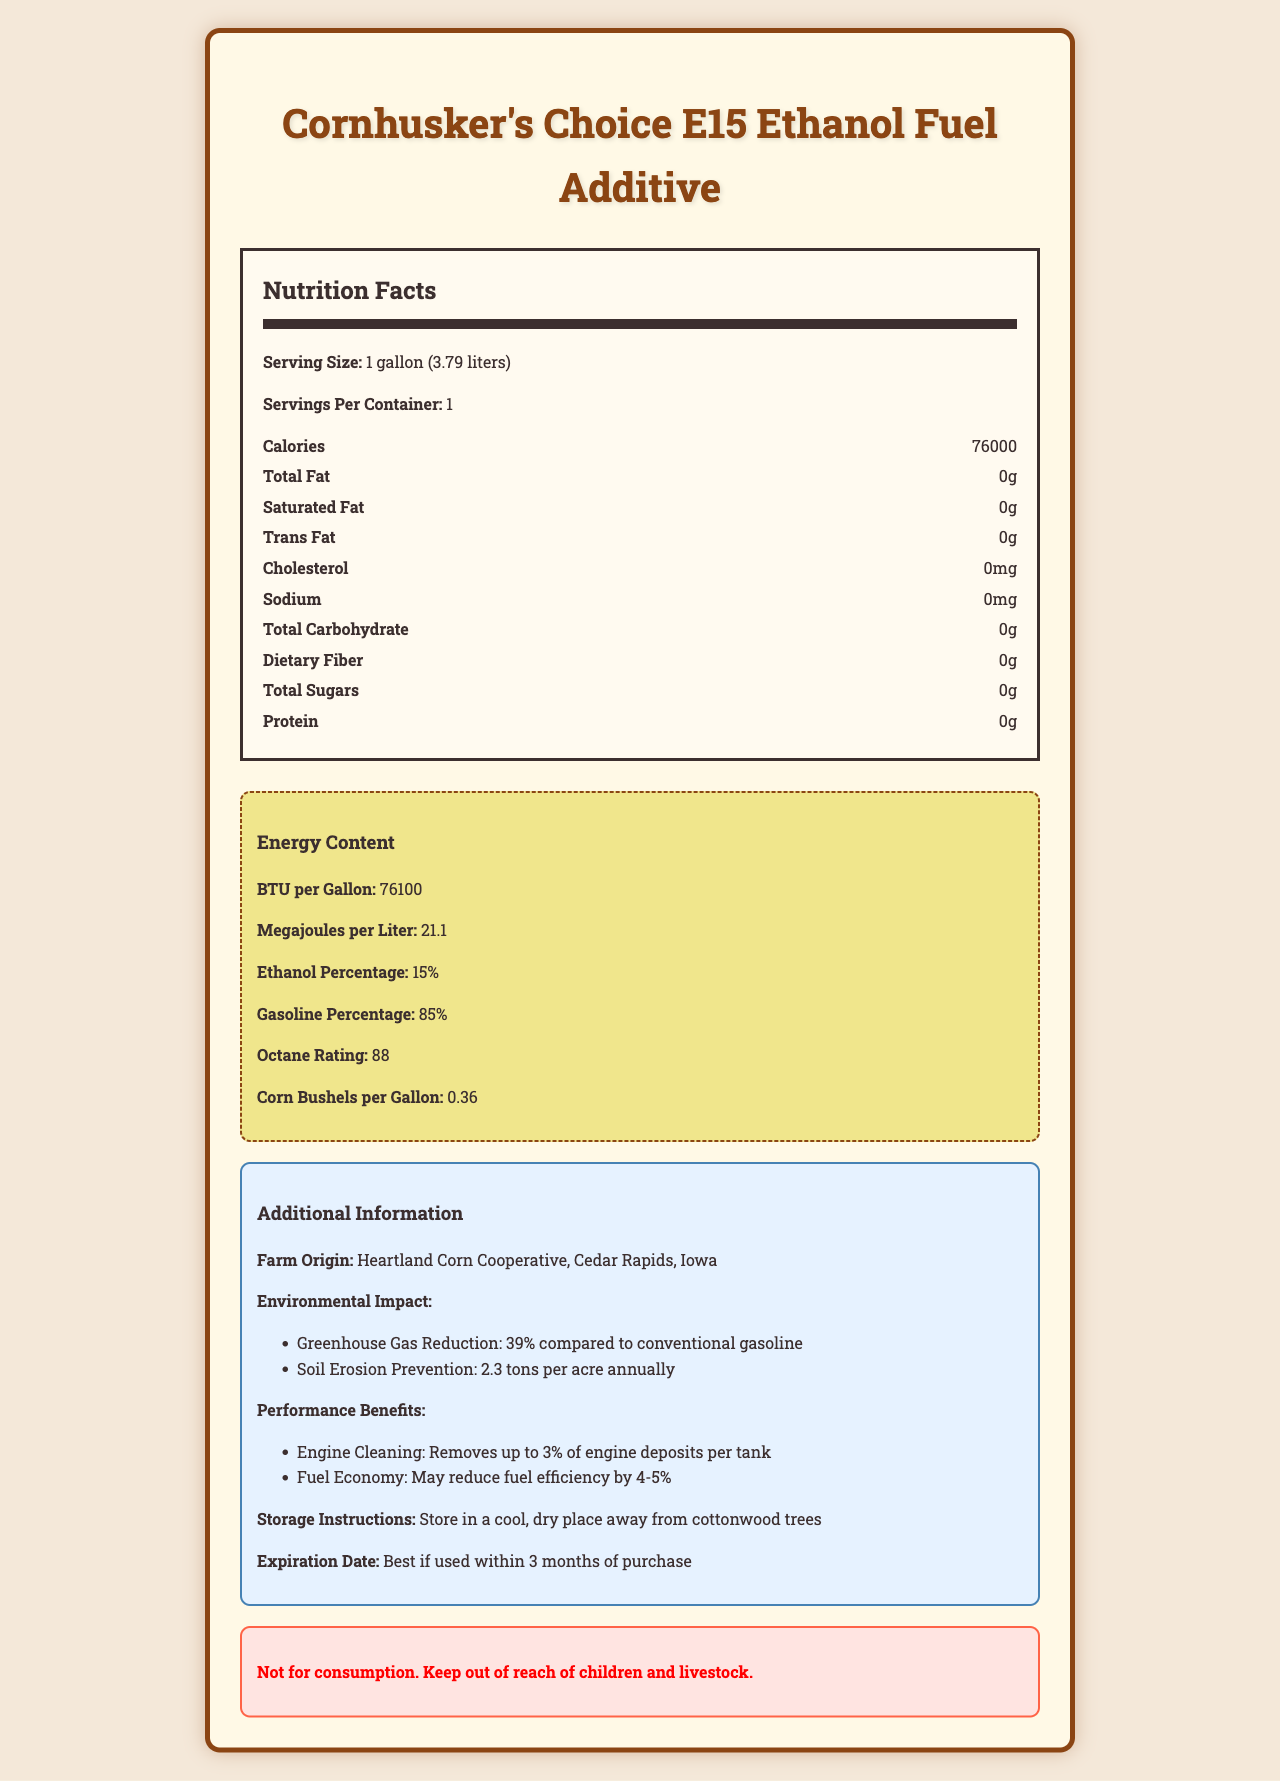what is the serving size for Cornhusker's Choice E15 Ethanol Fuel Additive? The serving size is explicitly stated as "1 gallon (3.79 liters)".
Answer: 1 gallon (3.79 liters) how many calories are in a serving of Cornhusker's Choice E15 Ethanol Fuel Additive? The document lists the calories as 76,000 per serving.
Answer: 76000 what is the BTU per gallon for Cornhusker's Choice E15 Ethanol Fuel Additive? The energy content section of the document states that it has 76,100 BTU per gallon.
Answer: 76100 list two performance benefits of the Cornhusker's Choice E15 Ethanol Fuel Additive. The performance benefits are specifically listed in the document.
Answer: Removes up to 3% of engine deposits per tank; May reduce fuel efficiency by 4-5% what percentage of the Cornhusker's Choice E15 Ethanol Fuel Additive is ethanol? The ethanol percentage is stated as 15% in the energy content section of the document.
Answer: 15% which of the following nutrients are present in Cornhusker's Choice E15 Ethanol Fuel Additive? A. Protein B. Sodium C. Total Fat D. None of the above The nutrition facts section indicates that all the listed nutrients (protein, sodium, total fat) are 0.
Answer: D. None of the above what is the octane rating of Cornhusker's Choice E15 Ethanol Fuel Additive? A. 85 B. 88 C. 90 D. 95 The octane rating is given as 88 in the energy content section.
Answer: B. 88 does Cornhusker's Choice E15 Ethanol Fuel Additive provide any vitamins or minerals? (Yes/No) The nutrition facts list shows 0% for Vitamin A, Vitamin C, calcium, iron, and potassium.
Answer: No summarize the main idea of the document. The document provides comprehensive information about Cornhusker's Choice E15 Ethanol Fuel Additive, detailing nutritional facts, energy content, environmental impact, performance benefits, and storage instructions.
Answer: The main idea of the document is to present the nutritional and energy content of Cornhusker's Choice E15 Ethanol Fuel Additive, focusing on its performance benefits, environmental impact, and storage instructions. It highlights attributes such as high BTU content, zero nutritional value, and the composition of ethanol and gasoline. who is the manufacturer of Cornhusker's Choice E15 Ethanol Fuel Additive? The farm origin section specifies the manufacturer as "Heartland Corn Cooperative, Cedar Rapids, Iowa".
Answer: Heartland Corn Cooperative, Cedar Rapids, Iowa how much can Cornhusker's Choice E15 Ethanol Fuel Additive reduce greenhouse gases compared to conventional gasoline? The document states that it reduces greenhouse gases by 39% compared to conventional gasoline.
Answer: 39% how many bushels of corn are used per gallon of Cornhusker's Choice E15 Ethanol Fuel Additive? The document mentions that 0.36 bushels of corn are used per gallon.
Answer: 0.36 what is the potential fuel economy impact when using Cornhusker's Choice E15 Ethanol Fuel Additive? One of the performance benefits listed is the potential reduction in fuel efficiency by 4-5%.
Answer: May reduce fuel efficiency by 4-5% is Cornhusker's Choice E15 Ethanol Fuel Additive suitable for consumption by humans or livestock? The warning section clearly states it is not for consumption and to keep it away from children and livestock.
Answer: Not for consumption. Keep out of reach of children and livestock. what are the storage instructions for Cornhusker's Choice E15 Ethanol Fuel Additive? The document advises storing the additive in a cool, dry place away from cottonwood trees.
Answer: Store in a cool, dry place away from cottonwood trees what specific temperature range is recommended for storing Cornhusker's Choice E15 Ethanol Fuel Additive? The document does not provide a specific temperature range for storage.
Answer: Not enough information 